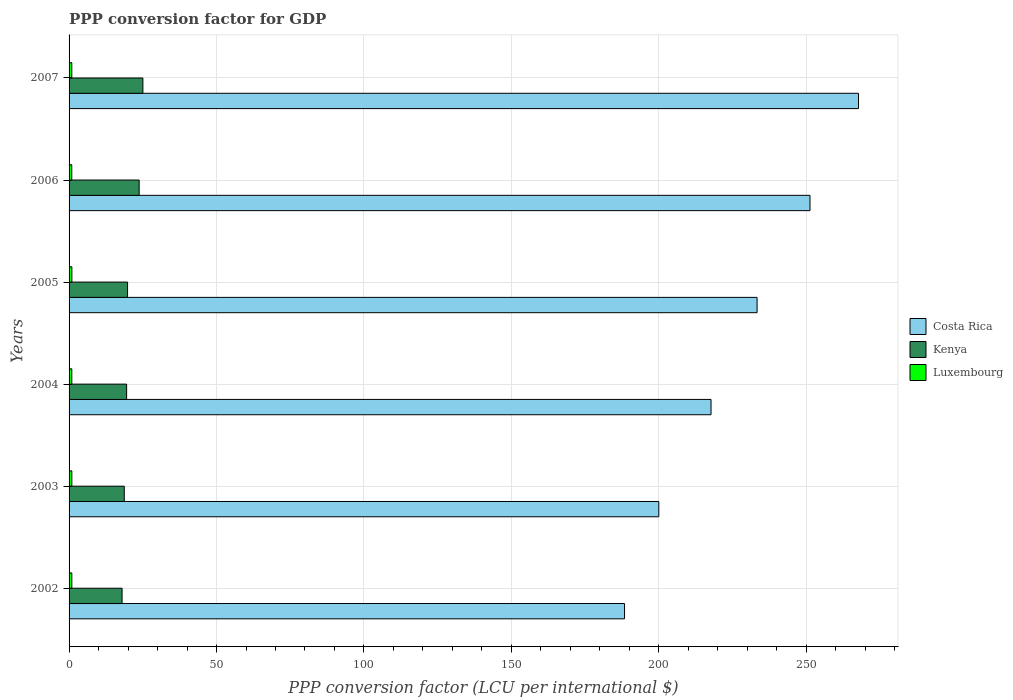How many different coloured bars are there?
Give a very brief answer. 3. How many groups of bars are there?
Offer a very short reply. 6. Are the number of bars per tick equal to the number of legend labels?
Make the answer very short. Yes. How many bars are there on the 2nd tick from the top?
Your answer should be very brief. 3. How many bars are there on the 5th tick from the bottom?
Offer a very short reply. 3. What is the PPP conversion factor for GDP in Luxembourg in 2006?
Make the answer very short. 0.91. Across all years, what is the maximum PPP conversion factor for GDP in Kenya?
Your answer should be very brief. 25.04. Across all years, what is the minimum PPP conversion factor for GDP in Kenya?
Provide a succinct answer. 17.98. In which year was the PPP conversion factor for GDP in Luxembourg maximum?
Your response must be concise. 2005. What is the total PPP conversion factor for GDP in Luxembourg in the graph?
Ensure brevity in your answer.  5.59. What is the difference between the PPP conversion factor for GDP in Costa Rica in 2005 and that in 2007?
Ensure brevity in your answer.  -34.4. What is the difference between the PPP conversion factor for GDP in Luxembourg in 2005 and the PPP conversion factor for GDP in Costa Rica in 2002?
Provide a succinct answer. -187.41. What is the average PPP conversion factor for GDP in Costa Rica per year?
Offer a terse response. 226.39. In the year 2004, what is the difference between the PPP conversion factor for GDP in Kenya and PPP conversion factor for GDP in Luxembourg?
Ensure brevity in your answer.  18.59. In how many years, is the PPP conversion factor for GDP in Luxembourg greater than 10 LCU?
Provide a succinct answer. 0. What is the ratio of the PPP conversion factor for GDP in Costa Rica in 2005 to that in 2006?
Your answer should be very brief. 0.93. Is the PPP conversion factor for GDP in Costa Rica in 2004 less than that in 2006?
Keep it short and to the point. Yes. Is the difference between the PPP conversion factor for GDP in Kenya in 2004 and 2007 greater than the difference between the PPP conversion factor for GDP in Luxembourg in 2004 and 2007?
Provide a succinct answer. No. What is the difference between the highest and the second highest PPP conversion factor for GDP in Kenya?
Give a very brief answer. 1.27. What is the difference between the highest and the lowest PPP conversion factor for GDP in Kenya?
Keep it short and to the point. 7.06. In how many years, is the PPP conversion factor for GDP in Luxembourg greater than the average PPP conversion factor for GDP in Luxembourg taken over all years?
Your answer should be very brief. 3. What does the 3rd bar from the top in 2005 represents?
Your response must be concise. Costa Rica. What does the 2nd bar from the bottom in 2006 represents?
Your answer should be very brief. Kenya. How many years are there in the graph?
Your response must be concise. 6. What is the difference between two consecutive major ticks on the X-axis?
Provide a short and direct response. 50. Does the graph contain any zero values?
Provide a succinct answer. No. What is the title of the graph?
Offer a terse response. PPP conversion factor for GDP. What is the label or title of the X-axis?
Provide a succinct answer. PPP conversion factor (LCU per international $). What is the label or title of the Y-axis?
Keep it short and to the point. Years. What is the PPP conversion factor (LCU per international $) of Costa Rica in 2002?
Offer a very short reply. 188.37. What is the PPP conversion factor (LCU per international $) in Kenya in 2002?
Make the answer very short. 17.98. What is the PPP conversion factor (LCU per international $) in Luxembourg in 2002?
Provide a succinct answer. 0.93. What is the PPP conversion factor (LCU per international $) of Costa Rica in 2003?
Your response must be concise. 199.99. What is the PPP conversion factor (LCU per international $) in Kenya in 2003?
Provide a short and direct response. 18.72. What is the PPP conversion factor (LCU per international $) of Luxembourg in 2003?
Your response must be concise. 0.94. What is the PPP conversion factor (LCU per international $) in Costa Rica in 2004?
Offer a very short reply. 217.69. What is the PPP conversion factor (LCU per international $) in Kenya in 2004?
Provide a short and direct response. 19.51. What is the PPP conversion factor (LCU per international $) of Luxembourg in 2004?
Your answer should be very brief. 0.92. What is the PPP conversion factor (LCU per international $) of Costa Rica in 2005?
Provide a succinct answer. 233.31. What is the PPP conversion factor (LCU per international $) in Kenya in 2005?
Offer a very short reply. 19.83. What is the PPP conversion factor (LCU per international $) of Luxembourg in 2005?
Your response must be concise. 0.95. What is the PPP conversion factor (LCU per international $) of Costa Rica in 2006?
Your answer should be very brief. 251.26. What is the PPP conversion factor (LCU per international $) in Kenya in 2006?
Ensure brevity in your answer.  23.77. What is the PPP conversion factor (LCU per international $) of Luxembourg in 2006?
Give a very brief answer. 0.91. What is the PPP conversion factor (LCU per international $) in Costa Rica in 2007?
Give a very brief answer. 267.71. What is the PPP conversion factor (LCU per international $) in Kenya in 2007?
Offer a very short reply. 25.04. What is the PPP conversion factor (LCU per international $) in Luxembourg in 2007?
Keep it short and to the point. 0.92. Across all years, what is the maximum PPP conversion factor (LCU per international $) of Costa Rica?
Ensure brevity in your answer.  267.71. Across all years, what is the maximum PPP conversion factor (LCU per international $) of Kenya?
Your response must be concise. 25.04. Across all years, what is the maximum PPP conversion factor (LCU per international $) of Luxembourg?
Your answer should be very brief. 0.95. Across all years, what is the minimum PPP conversion factor (LCU per international $) in Costa Rica?
Give a very brief answer. 188.37. Across all years, what is the minimum PPP conversion factor (LCU per international $) in Kenya?
Ensure brevity in your answer.  17.98. Across all years, what is the minimum PPP conversion factor (LCU per international $) in Luxembourg?
Provide a succinct answer. 0.91. What is the total PPP conversion factor (LCU per international $) in Costa Rica in the graph?
Provide a succinct answer. 1358.34. What is the total PPP conversion factor (LCU per international $) in Kenya in the graph?
Your answer should be very brief. 124.85. What is the total PPP conversion factor (LCU per international $) in Luxembourg in the graph?
Your response must be concise. 5.59. What is the difference between the PPP conversion factor (LCU per international $) in Costa Rica in 2002 and that in 2003?
Your answer should be very brief. -11.62. What is the difference between the PPP conversion factor (LCU per international $) of Kenya in 2002 and that in 2003?
Make the answer very short. -0.74. What is the difference between the PPP conversion factor (LCU per international $) in Luxembourg in 2002 and that in 2003?
Offer a terse response. -0.01. What is the difference between the PPP conversion factor (LCU per international $) in Costa Rica in 2002 and that in 2004?
Ensure brevity in your answer.  -29.33. What is the difference between the PPP conversion factor (LCU per international $) in Kenya in 2002 and that in 2004?
Provide a succinct answer. -1.54. What is the difference between the PPP conversion factor (LCU per international $) in Luxembourg in 2002 and that in 2004?
Provide a succinct answer. 0.01. What is the difference between the PPP conversion factor (LCU per international $) in Costa Rica in 2002 and that in 2005?
Make the answer very short. -44.95. What is the difference between the PPP conversion factor (LCU per international $) of Kenya in 2002 and that in 2005?
Provide a succinct answer. -1.86. What is the difference between the PPP conversion factor (LCU per international $) in Luxembourg in 2002 and that in 2005?
Your answer should be very brief. -0.02. What is the difference between the PPP conversion factor (LCU per international $) of Costa Rica in 2002 and that in 2006?
Your answer should be compact. -62.89. What is the difference between the PPP conversion factor (LCU per international $) of Kenya in 2002 and that in 2006?
Provide a short and direct response. -5.79. What is the difference between the PPP conversion factor (LCU per international $) of Luxembourg in 2002 and that in 2006?
Offer a terse response. 0.02. What is the difference between the PPP conversion factor (LCU per international $) in Costa Rica in 2002 and that in 2007?
Make the answer very short. -79.34. What is the difference between the PPP conversion factor (LCU per international $) in Kenya in 2002 and that in 2007?
Provide a short and direct response. -7.06. What is the difference between the PPP conversion factor (LCU per international $) in Luxembourg in 2002 and that in 2007?
Keep it short and to the point. 0.01. What is the difference between the PPP conversion factor (LCU per international $) in Costa Rica in 2003 and that in 2004?
Keep it short and to the point. -17.7. What is the difference between the PPP conversion factor (LCU per international $) in Kenya in 2003 and that in 2004?
Keep it short and to the point. -0.8. What is the difference between the PPP conversion factor (LCU per international $) in Luxembourg in 2003 and that in 2004?
Make the answer very short. 0.02. What is the difference between the PPP conversion factor (LCU per international $) of Costa Rica in 2003 and that in 2005?
Provide a succinct answer. -33.32. What is the difference between the PPP conversion factor (LCU per international $) of Kenya in 2003 and that in 2005?
Offer a terse response. -1.12. What is the difference between the PPP conversion factor (LCU per international $) of Luxembourg in 2003 and that in 2005?
Offer a terse response. -0.01. What is the difference between the PPP conversion factor (LCU per international $) of Costa Rica in 2003 and that in 2006?
Make the answer very short. -51.27. What is the difference between the PPP conversion factor (LCU per international $) of Kenya in 2003 and that in 2006?
Your answer should be very brief. -5.05. What is the difference between the PPP conversion factor (LCU per international $) in Luxembourg in 2003 and that in 2006?
Offer a very short reply. 0.03. What is the difference between the PPP conversion factor (LCU per international $) in Costa Rica in 2003 and that in 2007?
Your response must be concise. -67.72. What is the difference between the PPP conversion factor (LCU per international $) in Kenya in 2003 and that in 2007?
Keep it short and to the point. -6.32. What is the difference between the PPP conversion factor (LCU per international $) in Luxembourg in 2003 and that in 2007?
Provide a short and direct response. 0.02. What is the difference between the PPP conversion factor (LCU per international $) of Costa Rica in 2004 and that in 2005?
Your answer should be compact. -15.62. What is the difference between the PPP conversion factor (LCU per international $) in Kenya in 2004 and that in 2005?
Keep it short and to the point. -0.32. What is the difference between the PPP conversion factor (LCU per international $) in Luxembourg in 2004 and that in 2005?
Make the answer very short. -0.03. What is the difference between the PPP conversion factor (LCU per international $) in Costa Rica in 2004 and that in 2006?
Keep it short and to the point. -33.56. What is the difference between the PPP conversion factor (LCU per international $) of Kenya in 2004 and that in 2006?
Offer a very short reply. -4.25. What is the difference between the PPP conversion factor (LCU per international $) in Luxembourg in 2004 and that in 2006?
Keep it short and to the point. 0.01. What is the difference between the PPP conversion factor (LCU per international $) of Costa Rica in 2004 and that in 2007?
Your answer should be very brief. -50.02. What is the difference between the PPP conversion factor (LCU per international $) of Kenya in 2004 and that in 2007?
Offer a terse response. -5.52. What is the difference between the PPP conversion factor (LCU per international $) in Luxembourg in 2004 and that in 2007?
Provide a succinct answer. -0. What is the difference between the PPP conversion factor (LCU per international $) of Costa Rica in 2005 and that in 2006?
Your answer should be very brief. -17.94. What is the difference between the PPP conversion factor (LCU per international $) in Kenya in 2005 and that in 2006?
Your answer should be very brief. -3.94. What is the difference between the PPP conversion factor (LCU per international $) of Luxembourg in 2005 and that in 2006?
Offer a terse response. 0.04. What is the difference between the PPP conversion factor (LCU per international $) in Costa Rica in 2005 and that in 2007?
Give a very brief answer. -34.4. What is the difference between the PPP conversion factor (LCU per international $) of Kenya in 2005 and that in 2007?
Keep it short and to the point. -5.2. What is the difference between the PPP conversion factor (LCU per international $) in Luxembourg in 2005 and that in 2007?
Your answer should be very brief. 0.03. What is the difference between the PPP conversion factor (LCU per international $) in Costa Rica in 2006 and that in 2007?
Your answer should be compact. -16.45. What is the difference between the PPP conversion factor (LCU per international $) in Kenya in 2006 and that in 2007?
Offer a terse response. -1.27. What is the difference between the PPP conversion factor (LCU per international $) in Luxembourg in 2006 and that in 2007?
Ensure brevity in your answer.  -0.01. What is the difference between the PPP conversion factor (LCU per international $) in Costa Rica in 2002 and the PPP conversion factor (LCU per international $) in Kenya in 2003?
Give a very brief answer. 169.65. What is the difference between the PPP conversion factor (LCU per international $) in Costa Rica in 2002 and the PPP conversion factor (LCU per international $) in Luxembourg in 2003?
Offer a terse response. 187.43. What is the difference between the PPP conversion factor (LCU per international $) of Kenya in 2002 and the PPP conversion factor (LCU per international $) of Luxembourg in 2003?
Make the answer very short. 17.04. What is the difference between the PPP conversion factor (LCU per international $) of Costa Rica in 2002 and the PPP conversion factor (LCU per international $) of Kenya in 2004?
Your response must be concise. 168.85. What is the difference between the PPP conversion factor (LCU per international $) in Costa Rica in 2002 and the PPP conversion factor (LCU per international $) in Luxembourg in 2004?
Offer a very short reply. 187.44. What is the difference between the PPP conversion factor (LCU per international $) of Kenya in 2002 and the PPP conversion factor (LCU per international $) of Luxembourg in 2004?
Your answer should be compact. 17.05. What is the difference between the PPP conversion factor (LCU per international $) of Costa Rica in 2002 and the PPP conversion factor (LCU per international $) of Kenya in 2005?
Ensure brevity in your answer.  168.53. What is the difference between the PPP conversion factor (LCU per international $) in Costa Rica in 2002 and the PPP conversion factor (LCU per international $) in Luxembourg in 2005?
Offer a terse response. 187.41. What is the difference between the PPP conversion factor (LCU per international $) in Kenya in 2002 and the PPP conversion factor (LCU per international $) in Luxembourg in 2005?
Provide a succinct answer. 17.02. What is the difference between the PPP conversion factor (LCU per international $) of Costa Rica in 2002 and the PPP conversion factor (LCU per international $) of Kenya in 2006?
Ensure brevity in your answer.  164.6. What is the difference between the PPP conversion factor (LCU per international $) of Costa Rica in 2002 and the PPP conversion factor (LCU per international $) of Luxembourg in 2006?
Offer a terse response. 187.45. What is the difference between the PPP conversion factor (LCU per international $) in Kenya in 2002 and the PPP conversion factor (LCU per international $) in Luxembourg in 2006?
Provide a succinct answer. 17.06. What is the difference between the PPP conversion factor (LCU per international $) of Costa Rica in 2002 and the PPP conversion factor (LCU per international $) of Kenya in 2007?
Offer a very short reply. 163.33. What is the difference between the PPP conversion factor (LCU per international $) of Costa Rica in 2002 and the PPP conversion factor (LCU per international $) of Luxembourg in 2007?
Make the answer very short. 187.44. What is the difference between the PPP conversion factor (LCU per international $) in Kenya in 2002 and the PPP conversion factor (LCU per international $) in Luxembourg in 2007?
Make the answer very short. 17.05. What is the difference between the PPP conversion factor (LCU per international $) of Costa Rica in 2003 and the PPP conversion factor (LCU per international $) of Kenya in 2004?
Your answer should be compact. 180.48. What is the difference between the PPP conversion factor (LCU per international $) in Costa Rica in 2003 and the PPP conversion factor (LCU per international $) in Luxembourg in 2004?
Ensure brevity in your answer.  199.07. What is the difference between the PPP conversion factor (LCU per international $) in Kenya in 2003 and the PPP conversion factor (LCU per international $) in Luxembourg in 2004?
Offer a terse response. 17.8. What is the difference between the PPP conversion factor (LCU per international $) of Costa Rica in 2003 and the PPP conversion factor (LCU per international $) of Kenya in 2005?
Your answer should be compact. 180.16. What is the difference between the PPP conversion factor (LCU per international $) of Costa Rica in 2003 and the PPP conversion factor (LCU per international $) of Luxembourg in 2005?
Offer a very short reply. 199.04. What is the difference between the PPP conversion factor (LCU per international $) of Kenya in 2003 and the PPP conversion factor (LCU per international $) of Luxembourg in 2005?
Give a very brief answer. 17.76. What is the difference between the PPP conversion factor (LCU per international $) of Costa Rica in 2003 and the PPP conversion factor (LCU per international $) of Kenya in 2006?
Keep it short and to the point. 176.22. What is the difference between the PPP conversion factor (LCU per international $) of Costa Rica in 2003 and the PPP conversion factor (LCU per international $) of Luxembourg in 2006?
Make the answer very short. 199.08. What is the difference between the PPP conversion factor (LCU per international $) of Kenya in 2003 and the PPP conversion factor (LCU per international $) of Luxembourg in 2006?
Keep it short and to the point. 17.8. What is the difference between the PPP conversion factor (LCU per international $) of Costa Rica in 2003 and the PPP conversion factor (LCU per international $) of Kenya in 2007?
Make the answer very short. 174.96. What is the difference between the PPP conversion factor (LCU per international $) in Costa Rica in 2003 and the PPP conversion factor (LCU per international $) in Luxembourg in 2007?
Give a very brief answer. 199.07. What is the difference between the PPP conversion factor (LCU per international $) of Kenya in 2003 and the PPP conversion factor (LCU per international $) of Luxembourg in 2007?
Your answer should be compact. 17.79. What is the difference between the PPP conversion factor (LCU per international $) in Costa Rica in 2004 and the PPP conversion factor (LCU per international $) in Kenya in 2005?
Your answer should be very brief. 197.86. What is the difference between the PPP conversion factor (LCU per international $) of Costa Rica in 2004 and the PPP conversion factor (LCU per international $) of Luxembourg in 2005?
Give a very brief answer. 216.74. What is the difference between the PPP conversion factor (LCU per international $) in Kenya in 2004 and the PPP conversion factor (LCU per international $) in Luxembourg in 2005?
Your answer should be very brief. 18.56. What is the difference between the PPP conversion factor (LCU per international $) of Costa Rica in 2004 and the PPP conversion factor (LCU per international $) of Kenya in 2006?
Give a very brief answer. 193.93. What is the difference between the PPP conversion factor (LCU per international $) in Costa Rica in 2004 and the PPP conversion factor (LCU per international $) in Luxembourg in 2006?
Give a very brief answer. 216.78. What is the difference between the PPP conversion factor (LCU per international $) in Kenya in 2004 and the PPP conversion factor (LCU per international $) in Luxembourg in 2006?
Offer a very short reply. 18.6. What is the difference between the PPP conversion factor (LCU per international $) in Costa Rica in 2004 and the PPP conversion factor (LCU per international $) in Kenya in 2007?
Make the answer very short. 192.66. What is the difference between the PPP conversion factor (LCU per international $) of Costa Rica in 2004 and the PPP conversion factor (LCU per international $) of Luxembourg in 2007?
Your answer should be compact. 216.77. What is the difference between the PPP conversion factor (LCU per international $) of Kenya in 2004 and the PPP conversion factor (LCU per international $) of Luxembourg in 2007?
Keep it short and to the point. 18.59. What is the difference between the PPP conversion factor (LCU per international $) in Costa Rica in 2005 and the PPP conversion factor (LCU per international $) in Kenya in 2006?
Make the answer very short. 209.55. What is the difference between the PPP conversion factor (LCU per international $) in Costa Rica in 2005 and the PPP conversion factor (LCU per international $) in Luxembourg in 2006?
Your answer should be very brief. 232.4. What is the difference between the PPP conversion factor (LCU per international $) of Kenya in 2005 and the PPP conversion factor (LCU per international $) of Luxembourg in 2006?
Ensure brevity in your answer.  18.92. What is the difference between the PPP conversion factor (LCU per international $) in Costa Rica in 2005 and the PPP conversion factor (LCU per international $) in Kenya in 2007?
Your response must be concise. 208.28. What is the difference between the PPP conversion factor (LCU per international $) of Costa Rica in 2005 and the PPP conversion factor (LCU per international $) of Luxembourg in 2007?
Give a very brief answer. 232.39. What is the difference between the PPP conversion factor (LCU per international $) of Kenya in 2005 and the PPP conversion factor (LCU per international $) of Luxembourg in 2007?
Give a very brief answer. 18.91. What is the difference between the PPP conversion factor (LCU per international $) in Costa Rica in 2006 and the PPP conversion factor (LCU per international $) in Kenya in 2007?
Your response must be concise. 226.22. What is the difference between the PPP conversion factor (LCU per international $) in Costa Rica in 2006 and the PPP conversion factor (LCU per international $) in Luxembourg in 2007?
Provide a succinct answer. 250.33. What is the difference between the PPP conversion factor (LCU per international $) in Kenya in 2006 and the PPP conversion factor (LCU per international $) in Luxembourg in 2007?
Offer a terse response. 22.84. What is the average PPP conversion factor (LCU per international $) of Costa Rica per year?
Ensure brevity in your answer.  226.39. What is the average PPP conversion factor (LCU per international $) of Kenya per year?
Provide a short and direct response. 20.81. What is the average PPP conversion factor (LCU per international $) of Luxembourg per year?
Keep it short and to the point. 0.93. In the year 2002, what is the difference between the PPP conversion factor (LCU per international $) of Costa Rica and PPP conversion factor (LCU per international $) of Kenya?
Your answer should be compact. 170.39. In the year 2002, what is the difference between the PPP conversion factor (LCU per international $) in Costa Rica and PPP conversion factor (LCU per international $) in Luxembourg?
Provide a short and direct response. 187.43. In the year 2002, what is the difference between the PPP conversion factor (LCU per international $) in Kenya and PPP conversion factor (LCU per international $) in Luxembourg?
Offer a terse response. 17.04. In the year 2003, what is the difference between the PPP conversion factor (LCU per international $) of Costa Rica and PPP conversion factor (LCU per international $) of Kenya?
Your response must be concise. 181.27. In the year 2003, what is the difference between the PPP conversion factor (LCU per international $) in Costa Rica and PPP conversion factor (LCU per international $) in Luxembourg?
Your answer should be compact. 199.05. In the year 2003, what is the difference between the PPP conversion factor (LCU per international $) of Kenya and PPP conversion factor (LCU per international $) of Luxembourg?
Give a very brief answer. 17.78. In the year 2004, what is the difference between the PPP conversion factor (LCU per international $) of Costa Rica and PPP conversion factor (LCU per international $) of Kenya?
Offer a very short reply. 198.18. In the year 2004, what is the difference between the PPP conversion factor (LCU per international $) in Costa Rica and PPP conversion factor (LCU per international $) in Luxembourg?
Your response must be concise. 216.77. In the year 2004, what is the difference between the PPP conversion factor (LCU per international $) in Kenya and PPP conversion factor (LCU per international $) in Luxembourg?
Offer a terse response. 18.59. In the year 2005, what is the difference between the PPP conversion factor (LCU per international $) of Costa Rica and PPP conversion factor (LCU per international $) of Kenya?
Offer a very short reply. 213.48. In the year 2005, what is the difference between the PPP conversion factor (LCU per international $) in Costa Rica and PPP conversion factor (LCU per international $) in Luxembourg?
Offer a very short reply. 232.36. In the year 2005, what is the difference between the PPP conversion factor (LCU per international $) in Kenya and PPP conversion factor (LCU per international $) in Luxembourg?
Make the answer very short. 18.88. In the year 2006, what is the difference between the PPP conversion factor (LCU per international $) of Costa Rica and PPP conversion factor (LCU per international $) of Kenya?
Offer a very short reply. 227.49. In the year 2006, what is the difference between the PPP conversion factor (LCU per international $) of Costa Rica and PPP conversion factor (LCU per international $) of Luxembourg?
Ensure brevity in your answer.  250.34. In the year 2006, what is the difference between the PPP conversion factor (LCU per international $) in Kenya and PPP conversion factor (LCU per international $) in Luxembourg?
Provide a short and direct response. 22.86. In the year 2007, what is the difference between the PPP conversion factor (LCU per international $) in Costa Rica and PPP conversion factor (LCU per international $) in Kenya?
Your answer should be very brief. 242.68. In the year 2007, what is the difference between the PPP conversion factor (LCU per international $) in Costa Rica and PPP conversion factor (LCU per international $) in Luxembourg?
Offer a very short reply. 266.79. In the year 2007, what is the difference between the PPP conversion factor (LCU per international $) in Kenya and PPP conversion factor (LCU per international $) in Luxembourg?
Provide a succinct answer. 24.11. What is the ratio of the PPP conversion factor (LCU per international $) of Costa Rica in 2002 to that in 2003?
Your answer should be compact. 0.94. What is the ratio of the PPP conversion factor (LCU per international $) of Kenya in 2002 to that in 2003?
Offer a terse response. 0.96. What is the ratio of the PPP conversion factor (LCU per international $) of Luxembourg in 2002 to that in 2003?
Ensure brevity in your answer.  0.99. What is the ratio of the PPP conversion factor (LCU per international $) of Costa Rica in 2002 to that in 2004?
Give a very brief answer. 0.87. What is the ratio of the PPP conversion factor (LCU per international $) of Kenya in 2002 to that in 2004?
Keep it short and to the point. 0.92. What is the ratio of the PPP conversion factor (LCU per international $) in Luxembourg in 2002 to that in 2004?
Your answer should be very brief. 1.01. What is the ratio of the PPP conversion factor (LCU per international $) in Costa Rica in 2002 to that in 2005?
Ensure brevity in your answer.  0.81. What is the ratio of the PPP conversion factor (LCU per international $) in Kenya in 2002 to that in 2005?
Ensure brevity in your answer.  0.91. What is the ratio of the PPP conversion factor (LCU per international $) in Luxembourg in 2002 to that in 2005?
Provide a short and direct response. 0.98. What is the ratio of the PPP conversion factor (LCU per international $) in Costa Rica in 2002 to that in 2006?
Make the answer very short. 0.75. What is the ratio of the PPP conversion factor (LCU per international $) in Kenya in 2002 to that in 2006?
Your response must be concise. 0.76. What is the ratio of the PPP conversion factor (LCU per international $) in Luxembourg in 2002 to that in 2006?
Your answer should be very brief. 1.02. What is the ratio of the PPP conversion factor (LCU per international $) of Costa Rica in 2002 to that in 2007?
Give a very brief answer. 0.7. What is the ratio of the PPP conversion factor (LCU per international $) of Kenya in 2002 to that in 2007?
Offer a very short reply. 0.72. What is the ratio of the PPP conversion factor (LCU per international $) in Luxembourg in 2002 to that in 2007?
Your response must be concise. 1.01. What is the ratio of the PPP conversion factor (LCU per international $) in Costa Rica in 2003 to that in 2004?
Ensure brevity in your answer.  0.92. What is the ratio of the PPP conversion factor (LCU per international $) of Kenya in 2003 to that in 2004?
Make the answer very short. 0.96. What is the ratio of the PPP conversion factor (LCU per international $) in Luxembourg in 2003 to that in 2004?
Give a very brief answer. 1.02. What is the ratio of the PPP conversion factor (LCU per international $) of Costa Rica in 2003 to that in 2005?
Make the answer very short. 0.86. What is the ratio of the PPP conversion factor (LCU per international $) in Kenya in 2003 to that in 2005?
Keep it short and to the point. 0.94. What is the ratio of the PPP conversion factor (LCU per international $) of Luxembourg in 2003 to that in 2005?
Ensure brevity in your answer.  0.99. What is the ratio of the PPP conversion factor (LCU per international $) in Costa Rica in 2003 to that in 2006?
Your answer should be compact. 0.8. What is the ratio of the PPP conversion factor (LCU per international $) in Kenya in 2003 to that in 2006?
Offer a terse response. 0.79. What is the ratio of the PPP conversion factor (LCU per international $) of Luxembourg in 2003 to that in 2006?
Your answer should be compact. 1.03. What is the ratio of the PPP conversion factor (LCU per international $) in Costa Rica in 2003 to that in 2007?
Your answer should be compact. 0.75. What is the ratio of the PPP conversion factor (LCU per international $) in Kenya in 2003 to that in 2007?
Ensure brevity in your answer.  0.75. What is the ratio of the PPP conversion factor (LCU per international $) of Luxembourg in 2003 to that in 2007?
Your response must be concise. 1.02. What is the ratio of the PPP conversion factor (LCU per international $) in Costa Rica in 2004 to that in 2005?
Provide a succinct answer. 0.93. What is the ratio of the PPP conversion factor (LCU per international $) of Kenya in 2004 to that in 2005?
Your answer should be compact. 0.98. What is the ratio of the PPP conversion factor (LCU per international $) of Luxembourg in 2004 to that in 2005?
Keep it short and to the point. 0.97. What is the ratio of the PPP conversion factor (LCU per international $) of Costa Rica in 2004 to that in 2006?
Provide a short and direct response. 0.87. What is the ratio of the PPP conversion factor (LCU per international $) in Kenya in 2004 to that in 2006?
Give a very brief answer. 0.82. What is the ratio of the PPP conversion factor (LCU per international $) in Luxembourg in 2004 to that in 2006?
Ensure brevity in your answer.  1.01. What is the ratio of the PPP conversion factor (LCU per international $) of Costa Rica in 2004 to that in 2007?
Keep it short and to the point. 0.81. What is the ratio of the PPP conversion factor (LCU per international $) in Kenya in 2004 to that in 2007?
Your answer should be compact. 0.78. What is the ratio of the PPP conversion factor (LCU per international $) of Kenya in 2005 to that in 2006?
Offer a very short reply. 0.83. What is the ratio of the PPP conversion factor (LCU per international $) in Luxembourg in 2005 to that in 2006?
Give a very brief answer. 1.04. What is the ratio of the PPP conversion factor (LCU per international $) of Costa Rica in 2005 to that in 2007?
Keep it short and to the point. 0.87. What is the ratio of the PPP conversion factor (LCU per international $) of Kenya in 2005 to that in 2007?
Your response must be concise. 0.79. What is the ratio of the PPP conversion factor (LCU per international $) of Luxembourg in 2005 to that in 2007?
Your answer should be compact. 1.03. What is the ratio of the PPP conversion factor (LCU per international $) in Costa Rica in 2006 to that in 2007?
Keep it short and to the point. 0.94. What is the ratio of the PPP conversion factor (LCU per international $) of Kenya in 2006 to that in 2007?
Your answer should be very brief. 0.95. What is the ratio of the PPP conversion factor (LCU per international $) of Luxembourg in 2006 to that in 2007?
Ensure brevity in your answer.  0.99. What is the difference between the highest and the second highest PPP conversion factor (LCU per international $) of Costa Rica?
Make the answer very short. 16.45. What is the difference between the highest and the second highest PPP conversion factor (LCU per international $) of Kenya?
Ensure brevity in your answer.  1.27. What is the difference between the highest and the second highest PPP conversion factor (LCU per international $) of Luxembourg?
Your response must be concise. 0.01. What is the difference between the highest and the lowest PPP conversion factor (LCU per international $) in Costa Rica?
Your response must be concise. 79.34. What is the difference between the highest and the lowest PPP conversion factor (LCU per international $) in Kenya?
Ensure brevity in your answer.  7.06. What is the difference between the highest and the lowest PPP conversion factor (LCU per international $) in Luxembourg?
Your response must be concise. 0.04. 